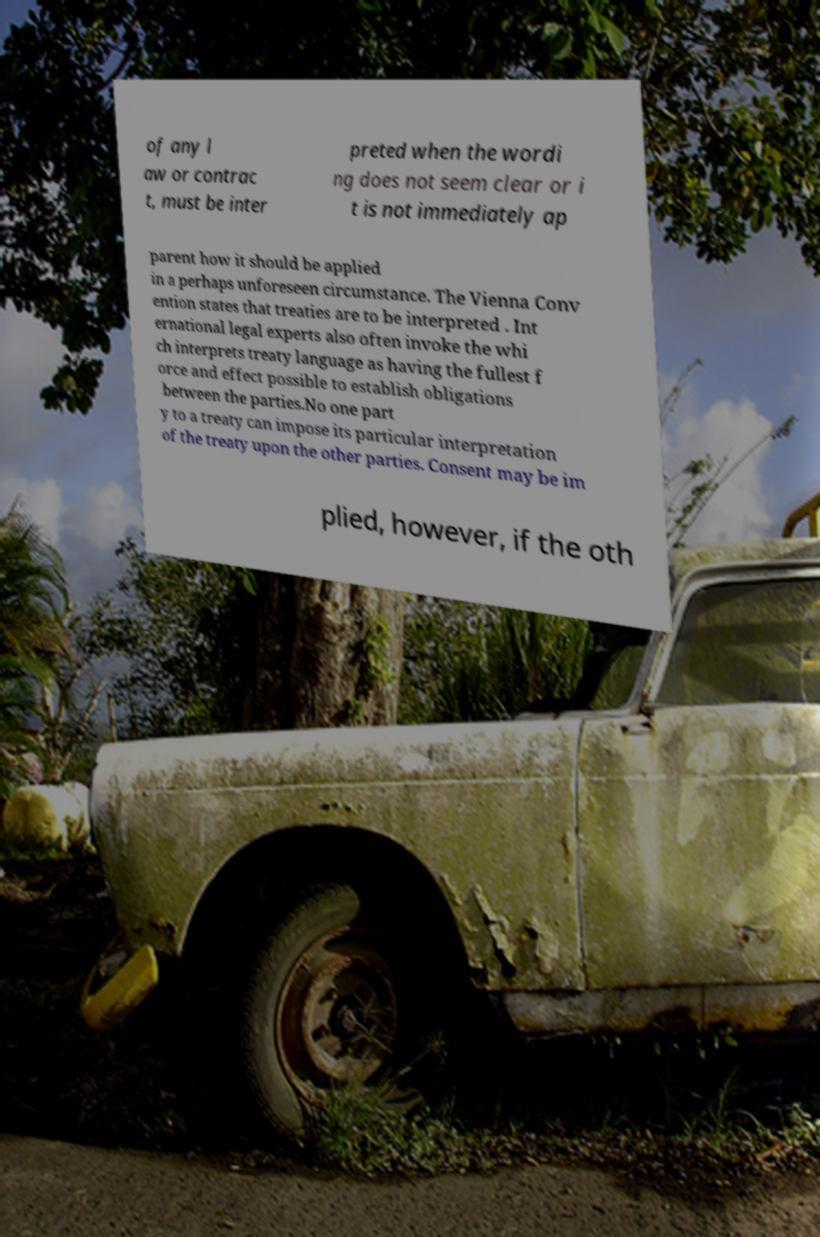Please identify and transcribe the text found in this image. of any l aw or contrac t, must be inter preted when the wordi ng does not seem clear or i t is not immediately ap parent how it should be applied in a perhaps unforeseen circumstance. The Vienna Conv ention states that treaties are to be interpreted . Int ernational legal experts also often invoke the whi ch interprets treaty language as having the fullest f orce and effect possible to establish obligations between the parties.No one part y to a treaty can impose its particular interpretation of the treaty upon the other parties. Consent may be im plied, however, if the oth 